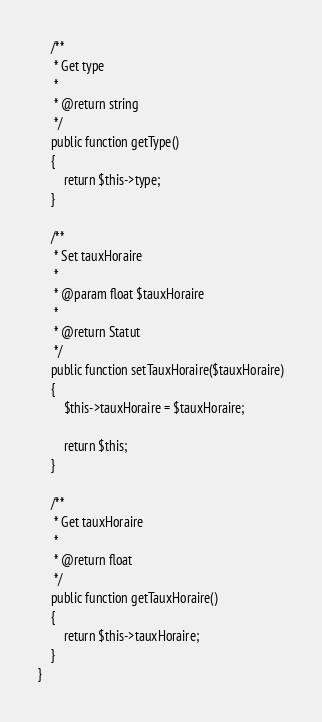Convert code to text. <code><loc_0><loc_0><loc_500><loc_500><_PHP_>    /**
     * Get type
     *
     * @return string
     */
    public function getType()
    {
        return $this->type;
    }

    /**
     * Set tauxHoraire
     *
     * @param float $tauxHoraire
     *
     * @return Statut
     */
    public function setTauxHoraire($tauxHoraire)
    {
        $this->tauxHoraire = $tauxHoraire;

        return $this;
    }

    /**
     * Get tauxHoraire
     *
     * @return float
     */
    public function getTauxHoraire()
    {
        return $this->tauxHoraire;
    }
}

</code> 